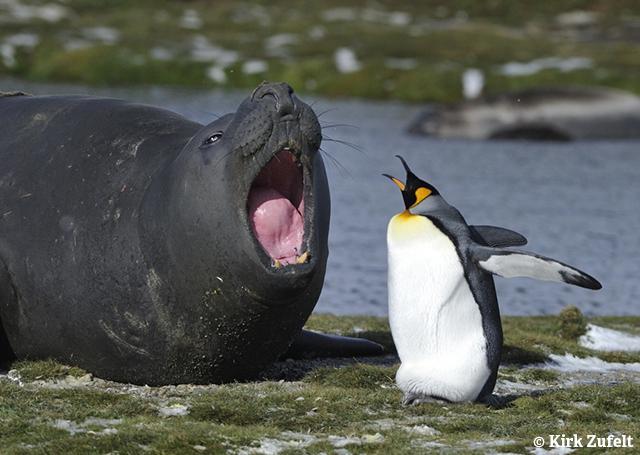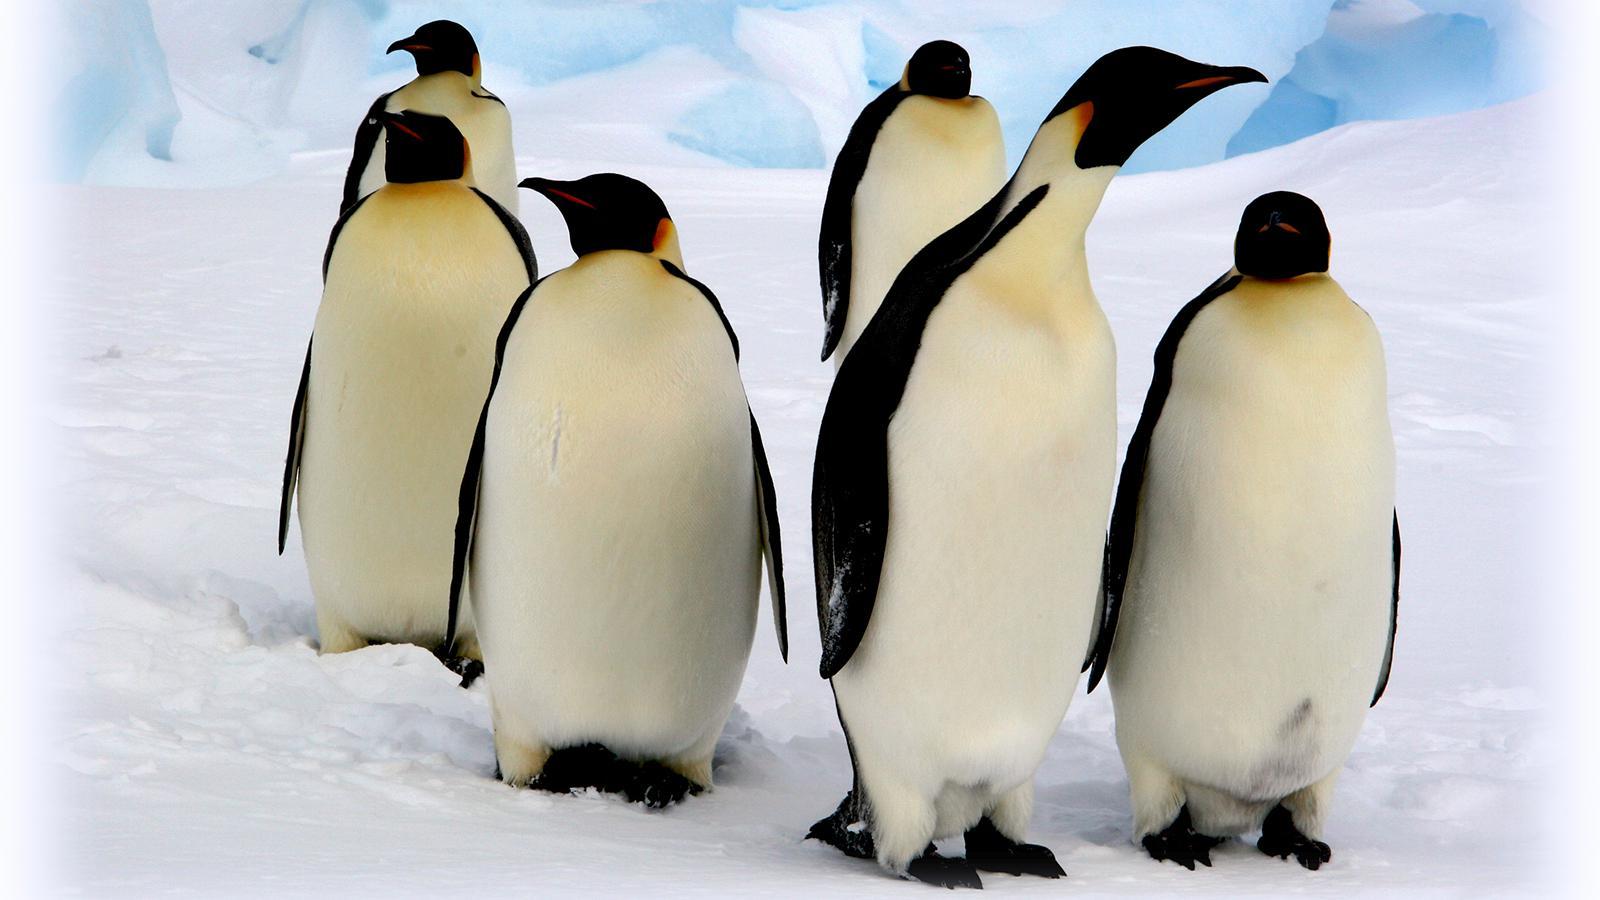The first image is the image on the left, the second image is the image on the right. Given the left and right images, does the statement "There is less than four penguins in at least one of the images." hold true? Answer yes or no. Yes. The first image is the image on the left, the second image is the image on the right. Analyze the images presented: Is the assertion "An image shows a flock of mostly brown-feathered penguins." valid? Answer yes or no. No. 